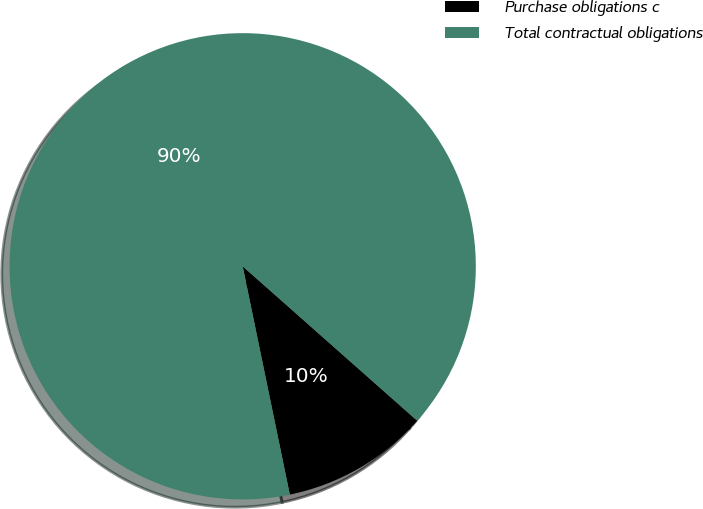<chart> <loc_0><loc_0><loc_500><loc_500><pie_chart><fcel>Purchase obligations c<fcel>Total contractual obligations<nl><fcel>10.23%<fcel>89.77%<nl></chart> 